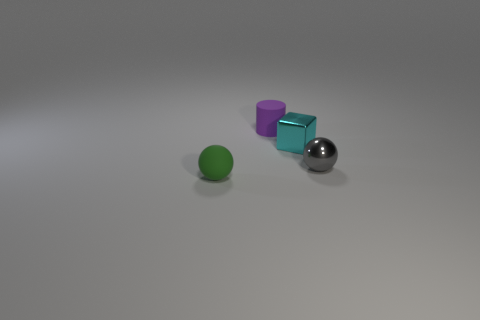What is the size of the thing that is both behind the gray metal ball and to the right of the purple thing?
Provide a succinct answer. Small. Are there any small objects of the same color as the cylinder?
Your response must be concise. No. The thing behind the cyan metallic cube that is in front of the tiny purple matte object is what color?
Ensure brevity in your answer.  Purple. Is the number of tiny spheres on the left side of the green sphere less than the number of blocks in front of the gray metallic ball?
Your answer should be compact. No. Is the size of the metallic block the same as the gray metal ball?
Offer a terse response. Yes. The object that is both in front of the metallic block and behind the tiny green ball has what shape?
Give a very brief answer. Sphere. How many tiny balls are the same material as the cylinder?
Provide a succinct answer. 1. There is a object on the right side of the cyan metal thing; how many tiny purple objects are left of it?
Offer a terse response. 1. What shape is the tiny thing on the left side of the matte thing behind the tiny ball that is to the left of the purple matte thing?
Your answer should be very brief. Sphere. How many things are either large cyan spheres or purple things?
Keep it short and to the point. 1. 